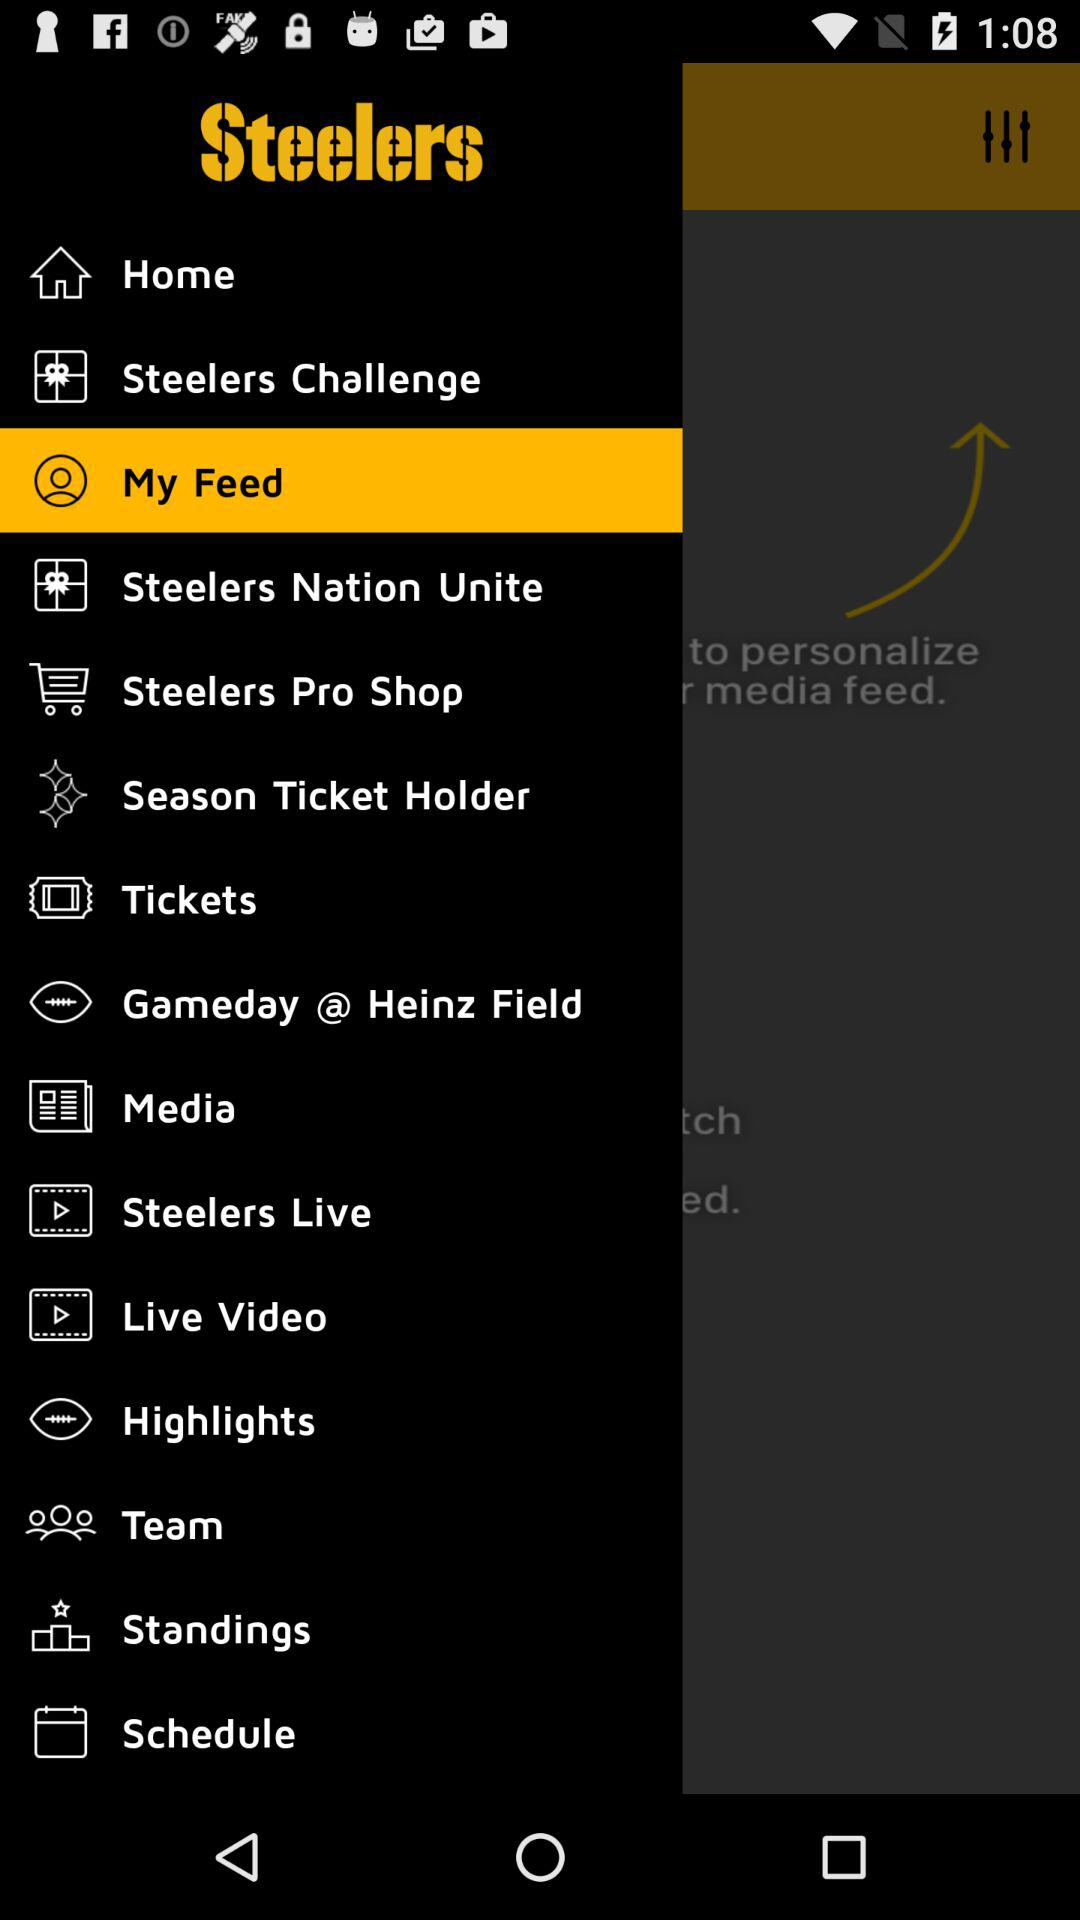What is the application name? The application name is "Steelers". 